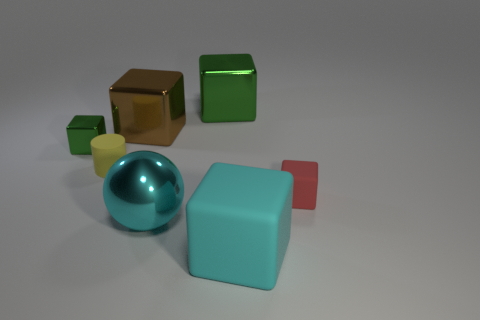Are there the same number of tiny yellow matte things that are behind the large green metallic thing and objects behind the red cube?
Your response must be concise. No. Are there more small cubes than purple rubber objects?
Provide a short and direct response. Yes. What number of shiny things are either yellow objects or small gray cubes?
Make the answer very short. 0. What number of large metal objects are the same color as the small cylinder?
Give a very brief answer. 0. There is a small thing that is in front of the small rubber thing behind the small block on the right side of the cyan matte block; what is its material?
Offer a terse response. Rubber. The shiny cube that is in front of the large metallic block on the left side of the big cyan sphere is what color?
Make the answer very short. Green. How many small objects are either metallic objects or brown metallic cubes?
Offer a very short reply. 1. How many tiny yellow things are made of the same material as the big green object?
Your answer should be very brief. 0. What is the size of the cyan sphere in front of the red thing?
Ensure brevity in your answer.  Large. What is the shape of the tiny thing in front of the matte cylinder that is in front of the large green shiny object?
Provide a succinct answer. Cube. 